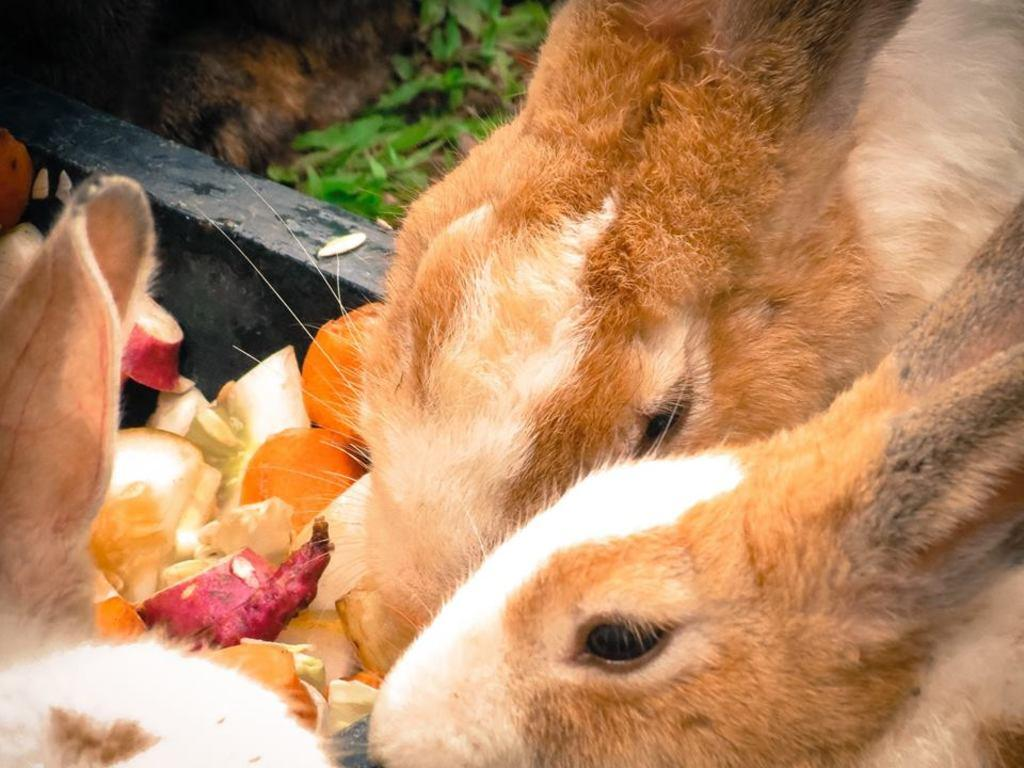What animals are present in the image? There are rabbits in the image. What are the rabbits doing in the image? The rabbits are eating food in the image. What type of environment is depicted in the image? There is grass on the ground in the image, suggesting an outdoor or natural setting. What type of statement is being made by the fireman in the image? There is no fireman present in the image; it features rabbits eating food in an outdoor or natural setting. 